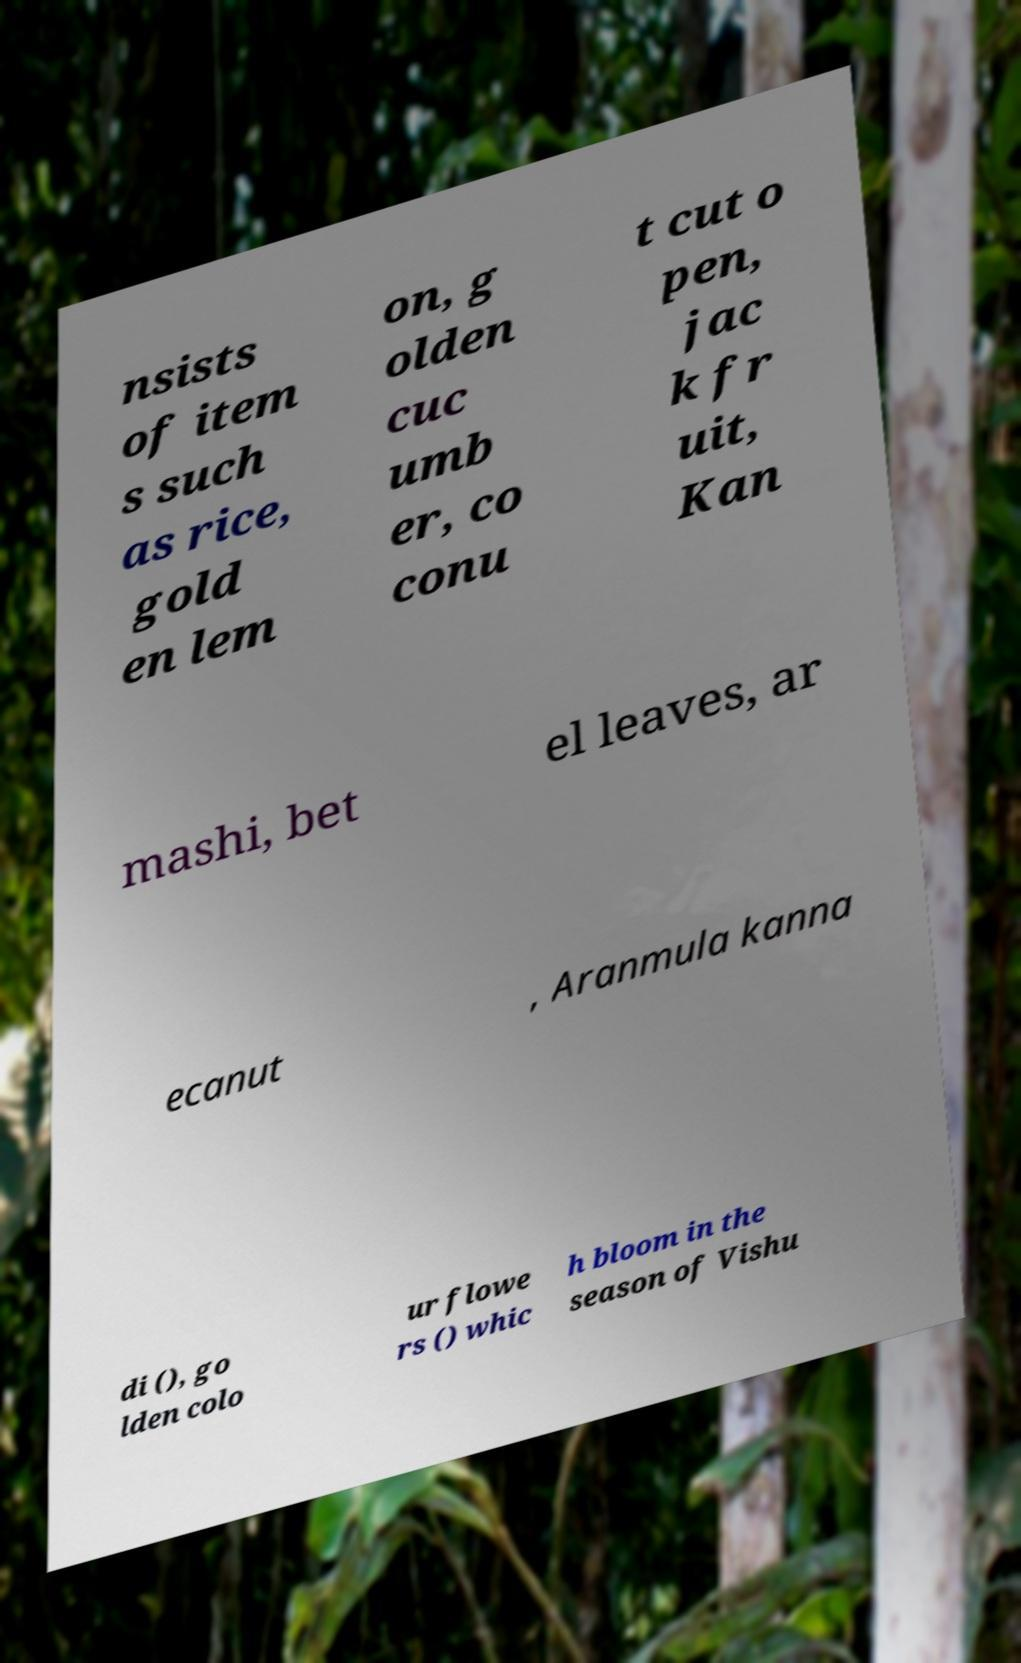Please read and relay the text visible in this image. What does it say? nsists of item s such as rice, gold en lem on, g olden cuc umb er, co conu t cut o pen, jac k fr uit, Kan mashi, bet el leaves, ar ecanut , Aranmula kanna di (), go lden colo ur flowe rs () whic h bloom in the season of Vishu 